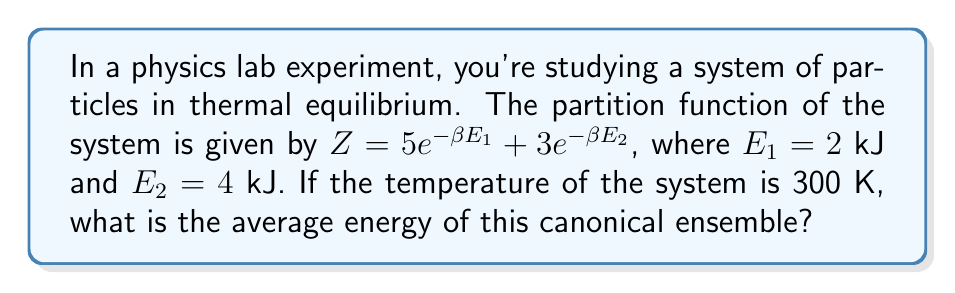Solve this math problem. To solve this problem, we'll follow these steps:

1) Recall that the average energy of a canonical ensemble is given by:
   
   $$\langle E \rangle = -\frac{\partial \ln Z}{\partial \beta}$$

2) First, we need to calculate $\beta$:
   
   $\beta = \frac{1}{k_B T}$, where $k_B$ is Boltzmann's constant ($1.380649 \times 10^{-23}$ J/K)
   
   $\beta = \frac{1}{(1.380649 \times 10^{-23} \text{ J/K})(300 \text{ K})} = 2.4151 \times 10^{20}$ J^(-1)

3) Now, let's calculate $\ln Z$:
   
   $$\ln Z = \ln(5e^{-\beta E_1} + 3e^{-\beta E_2})$$

4) Next, we need to find $\frac{\partial \ln Z}{\partial \beta}$:

   $$\frac{\partial \ln Z}{\partial \beta} = \frac{-5E_1e^{-\beta E_1} - 3E_2e^{-\beta E_2}}{5e^{-\beta E_1} + 3e^{-\beta E_2}}$$

5) Now we can calculate the average energy:

   $$\langle E \rangle = -\frac{\partial \ln Z}{\partial \beta} = \frac{5E_1e^{-\beta E_1} + 3E_2e^{-\beta E_2}}{5e^{-\beta E_1} + 3e^{-\beta E_2}}$$

6) Plugging in the values:

   $$\langle E \rangle = \frac{5(2000 \text{ J})e^{-(2.4151 \times 10^{20} \text{ J}^{-1})(2000 \text{ J})} + 3(4000 \text{ J})e^{-(2.4151 \times 10^{20} \text{ J}^{-1})(4000 \text{ J})}}{5e^{-(2.4151 \times 10^{20} \text{ J}^{-1})(2000 \text{ J})} + 3e^{-(2.4151 \times 10^{20} \text{ J}^{-1})(4000 \text{ J})}}$$

7) Calculating this gives us the average energy.
Answer: $\langle E \rangle \approx 2.287$ kJ 